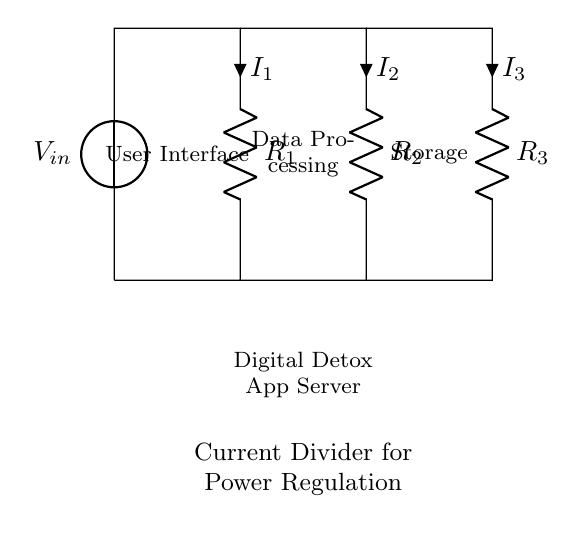What type of circuit is represented? The circuit is a parallel circuit, identified by multiple branches with common voltage across each resistor.
Answer: Parallel circuit How many resistors are in the circuit? There are three resistors displayed in the circuit diagram, denoted as R1, R2, and R3.
Answer: Three What is the function of the user interface component? The user interface serves as the input section for user interactions with the digital detox app server.
Answer: Input section How does current divide among the resistors? The current divides among the resistors based on their resistances; lower resistance will draw more current.
Answer: Based on resistance What is the total current entering the circuit? The total current is the sum of the individual currents through each resistor as per the current divider rule.
Answer: Sum of currents Which component utilizes the highest current based on its resistance? The component with the least resistance among R1, R2, and R3 will carry the highest current.
Answer: Lowest resistance What is the impact of increasing R1 on I1? Increasing R1 will decrease I1 because current is inversely proportional to resistance in a parallel circuit.
Answer: Decrease I1 